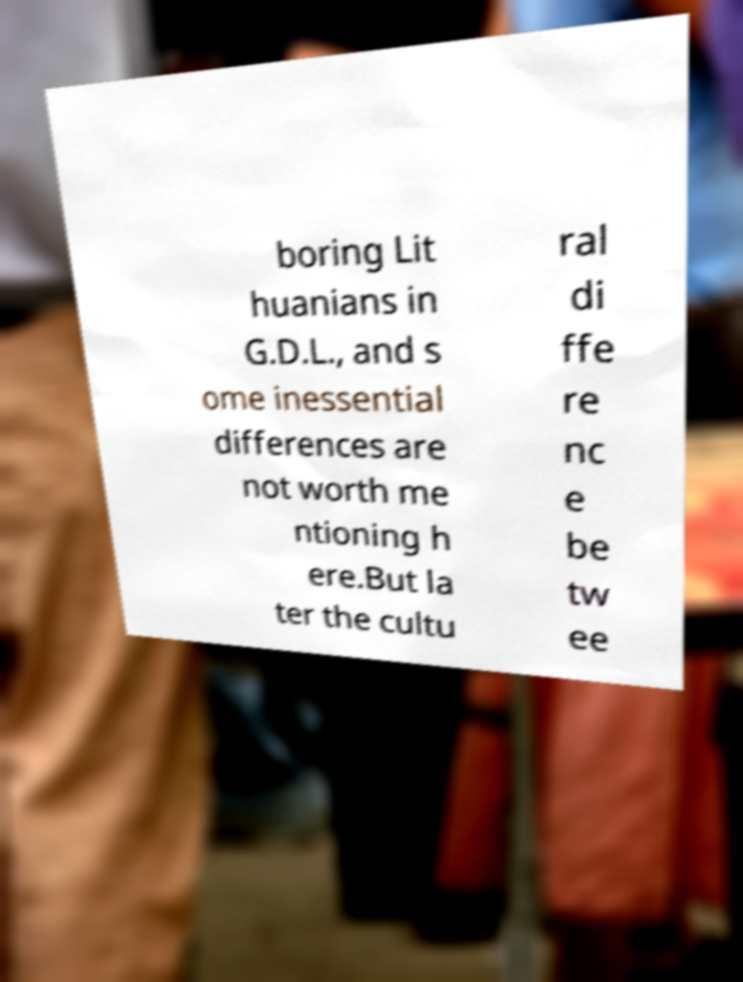There's text embedded in this image that I need extracted. Can you transcribe it verbatim? boring Lit huanians in G.D.L., and s ome inessential differences are not worth me ntioning h ere.But la ter the cultu ral di ffe re nc e be tw ee 